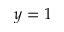<formula> <loc_0><loc_0><loc_500><loc_500>y = 1</formula> 